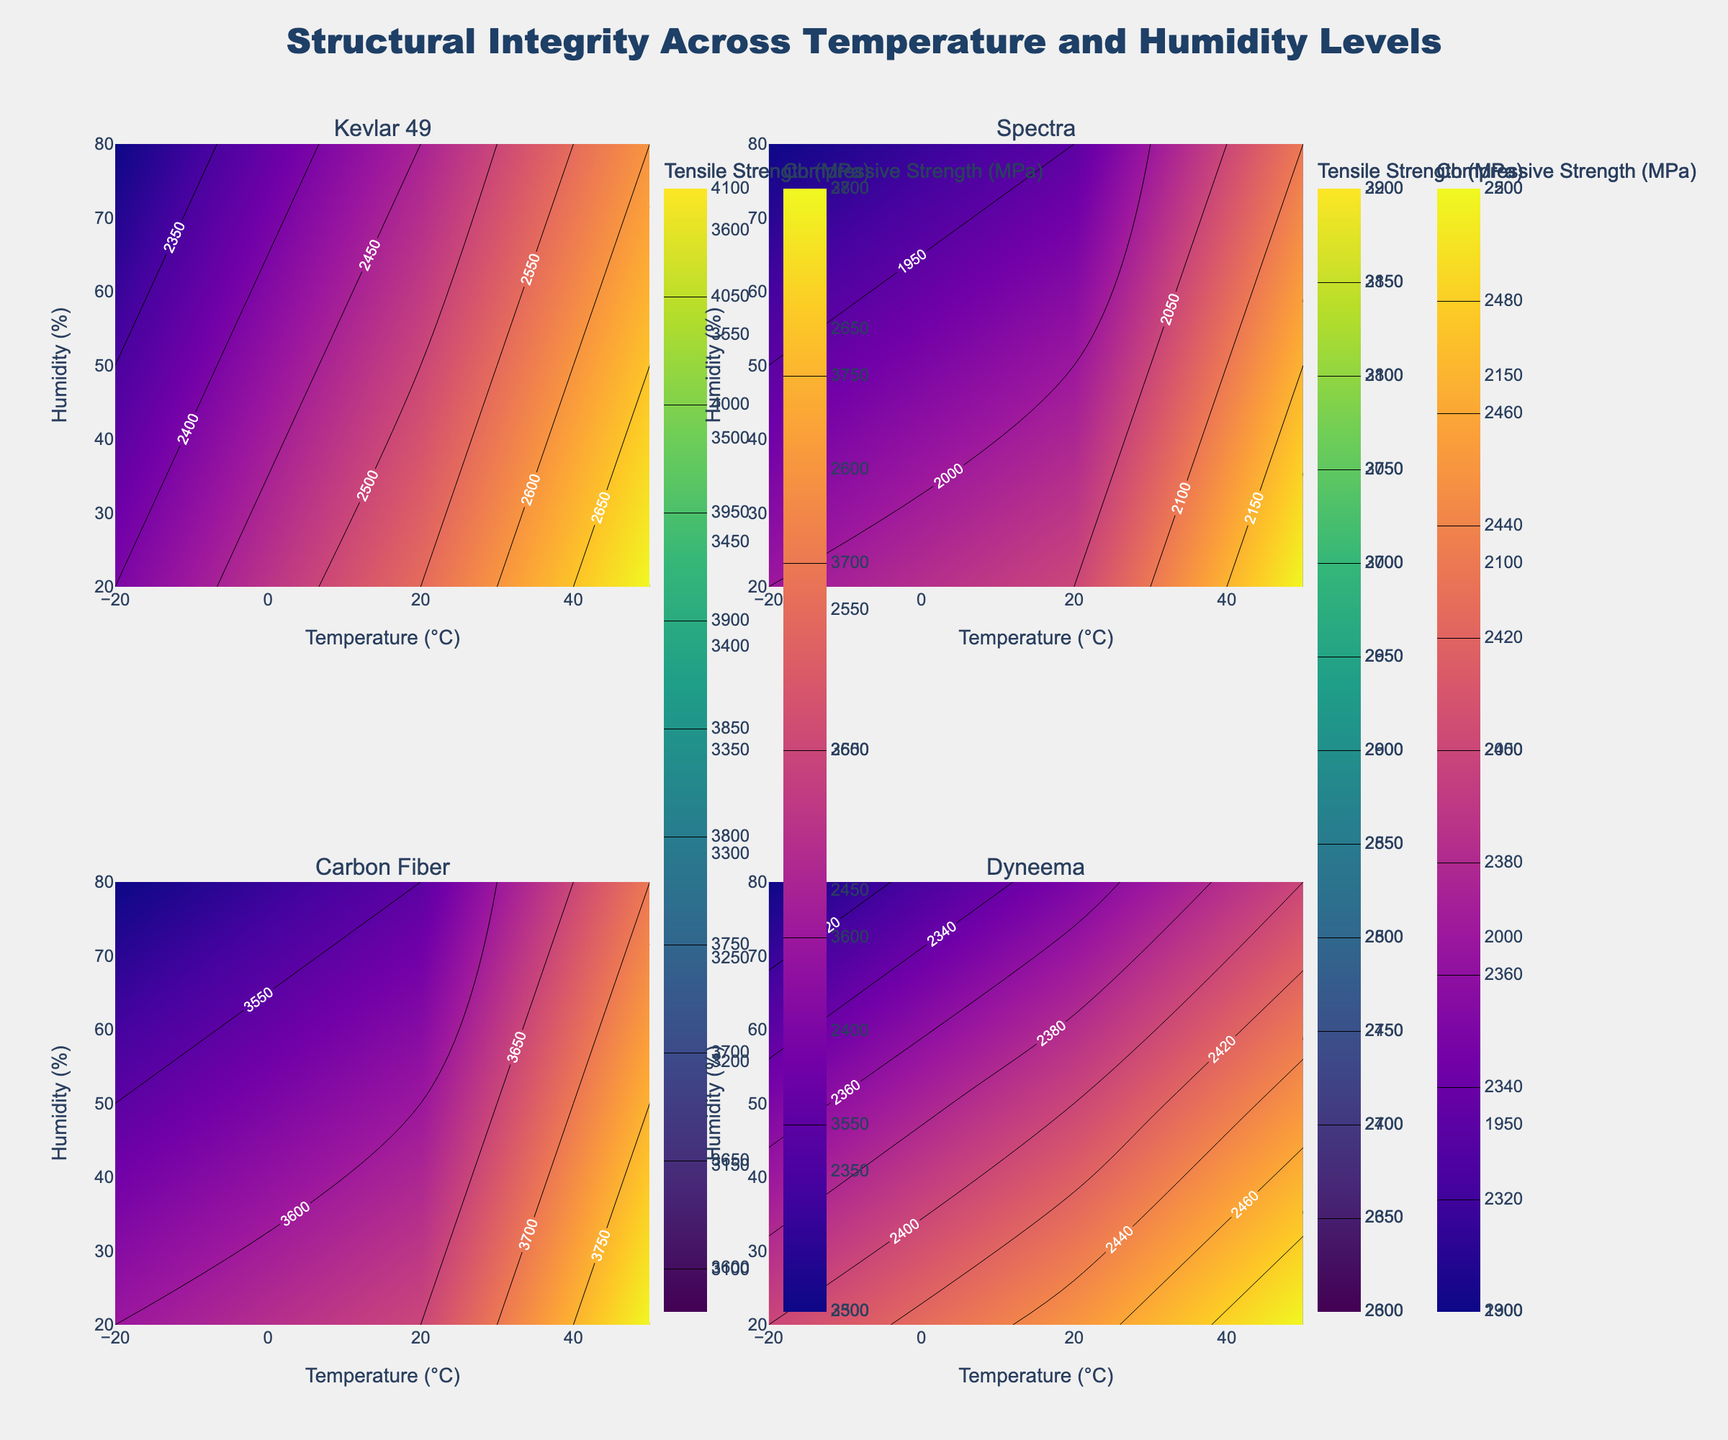What is the title of the figure? The title of the figure is prominently displayed at the top and reads "Structural Integrity Across Temperature and Humidity Levels."
Answer: Structural Integrity Across Temperature and Humidity Levels How many materials are compared in the subplots? The figure contains four subplots, each representing a different material.
Answer: 4 What is the color scheme used to represent tensile strength? The color scheme for tensile strength uses a Viridis colorscale, which ranges from dark blue to bright yellow.
Answer: Viridis Which material shows the highest tensile strength at -20°C and 20% humidity? Examining the contour plot for each material at the specified temperature and humidity conditions reveals that Carbon Fiber has the highest tensile strength in this scenario.
Answer: Carbon Fiber What are the axis labels of the charts? The x-axis is labeled "Temperature (°C)" and the y-axis is labeled "Humidity (%)."
Answer: Temperature (°C), Humidity (%) In which scenario does Kevlar 49 show the highest compressive strength? By looking at the compressive strength contour plot for Kevlar 49, the highest value occurs at 50°C and 20% humidity.
Answer: 50°C and 20% humidity Compare the tensile strength of Spectra and Dyneema at 50°C and 50% humidity. Which one is higher? By examining the corresponding contour plots, the tensile strength of Dyneema (2670 MPa) is higher than that of Spectra (2370 MPa) at 50°C and 50% humidity.
Answer: Dyneema Which material shows the least variation in compressive strength across all temperatures and humidity levels? Analyzing the compressive strength contour plots for each material, Carbon Fiber shows the least variation, maintaining relatively high and stable values across different conditions.
Answer: Carbon Fiber Which material's tensile strength decreases most substantially from -20°C to 50°C at 20% humidity? Observing the tensile strength contour plots, Kevlar 49's tensile strength drops from 3620 MPa to 3200 MPa, indicating the most substantial decrease among the materials.
Answer: Kevlar 49 What is the tensile strength for Spectra at 20°C and 80% humidity? By checking the tensile strength contour plot for Spectra at the specified conditions, the value is 2530 MPa.
Answer: 2530 MPa 